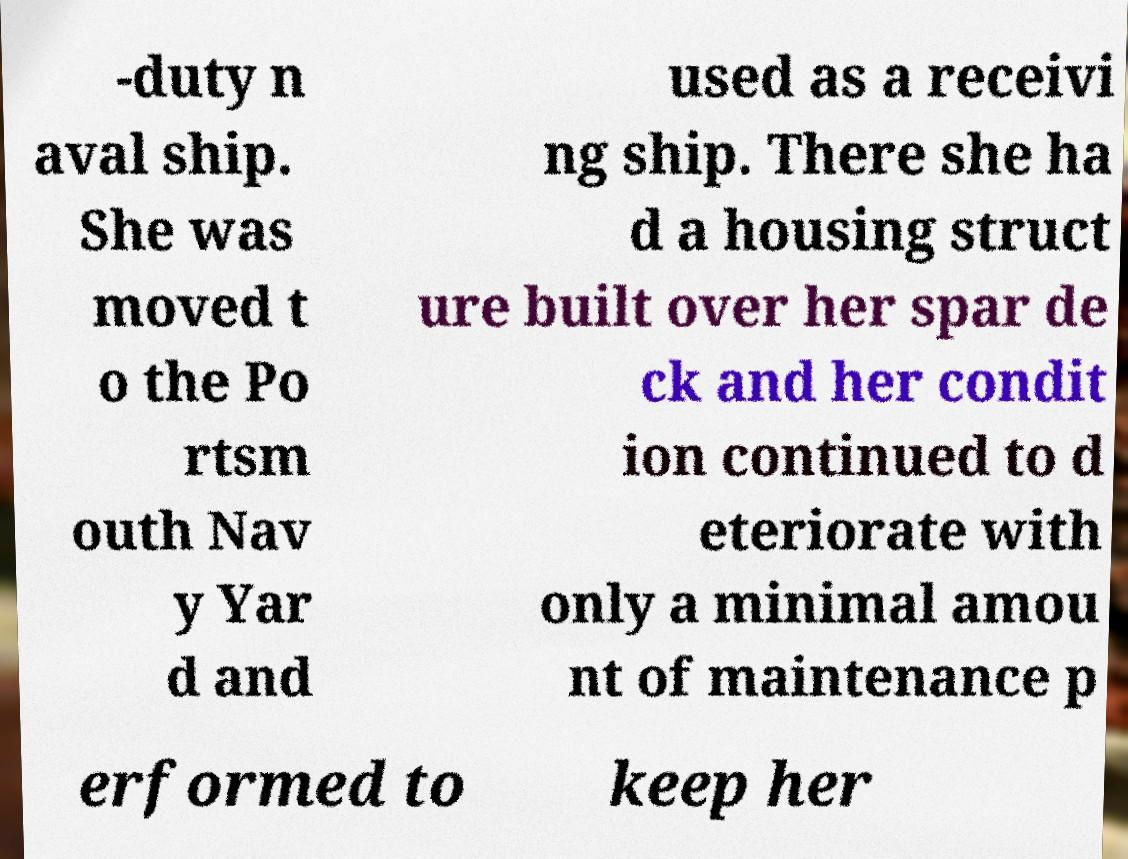For documentation purposes, I need the text within this image transcribed. Could you provide that? -duty n aval ship. She was moved t o the Po rtsm outh Nav y Yar d and used as a receivi ng ship. There she ha d a housing struct ure built over her spar de ck and her condit ion continued to d eteriorate with only a minimal amou nt of maintenance p erformed to keep her 